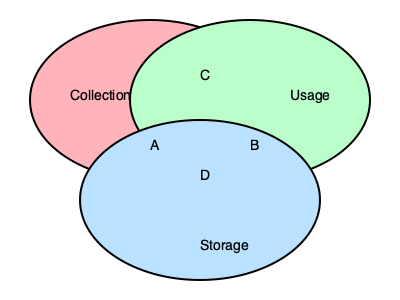In the Venn diagram above, which area represents personal data that is collected, used, and stored by businesses, potentially posing the highest risk to customer privacy? To answer this question, we need to understand what each circle and intersection represents:

1. The pink circle represents data collection.
2. The green circle represents data usage.
3. The blue circle represents data storage.

Now, let's analyze the intersections:

A. Intersection of collection and storage only
B. Intersection of usage and storage only
C. Intersection of collection and usage only
D. Intersection of all three: collection, usage, and storage

The area that represents personal data collected, used, and stored by businesses is the central intersection where all three circles overlap, labeled as "D" in the diagram.

This area poses the highest risk to customer privacy because:
1. The data is collected, meaning the business has obtained it from customers.
2. The data is being used, potentially for various purposes.
3. The data is also being stored, which means it's retained by the business for some time.

When data falls into all three categories, it's more vulnerable to potential breaches, misuse, or unauthorized access, thus presenting the highest risk to customer privacy.
Answer: D 